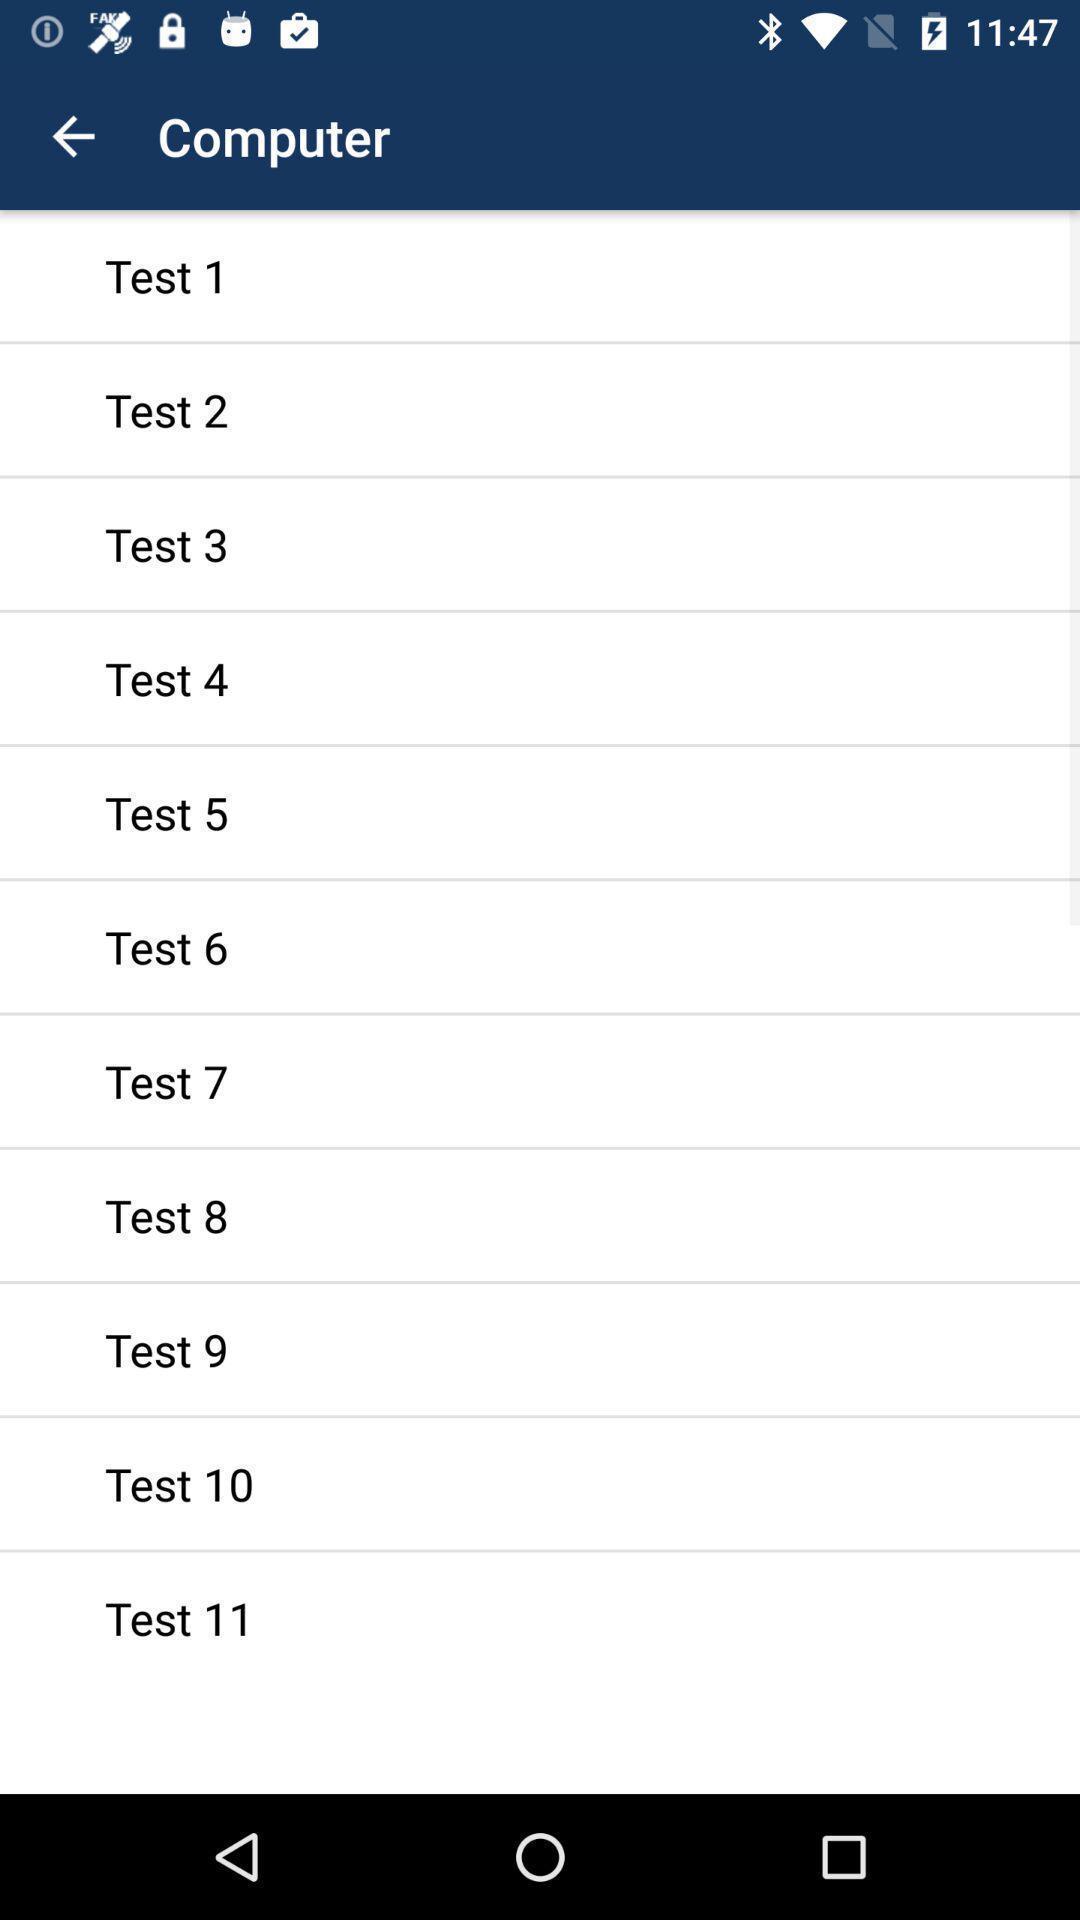What is the overall content of this screenshot? Page showing list of tests. 